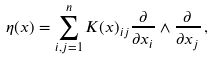<formula> <loc_0><loc_0><loc_500><loc_500>\eta ( x ) = \sum _ { i , j = 1 } ^ { n } K ( x ) _ { i j } \frac { \partial } { \partial x _ { i } } \wedge \frac { \partial } { \partial x _ { j } } \, ,</formula> 